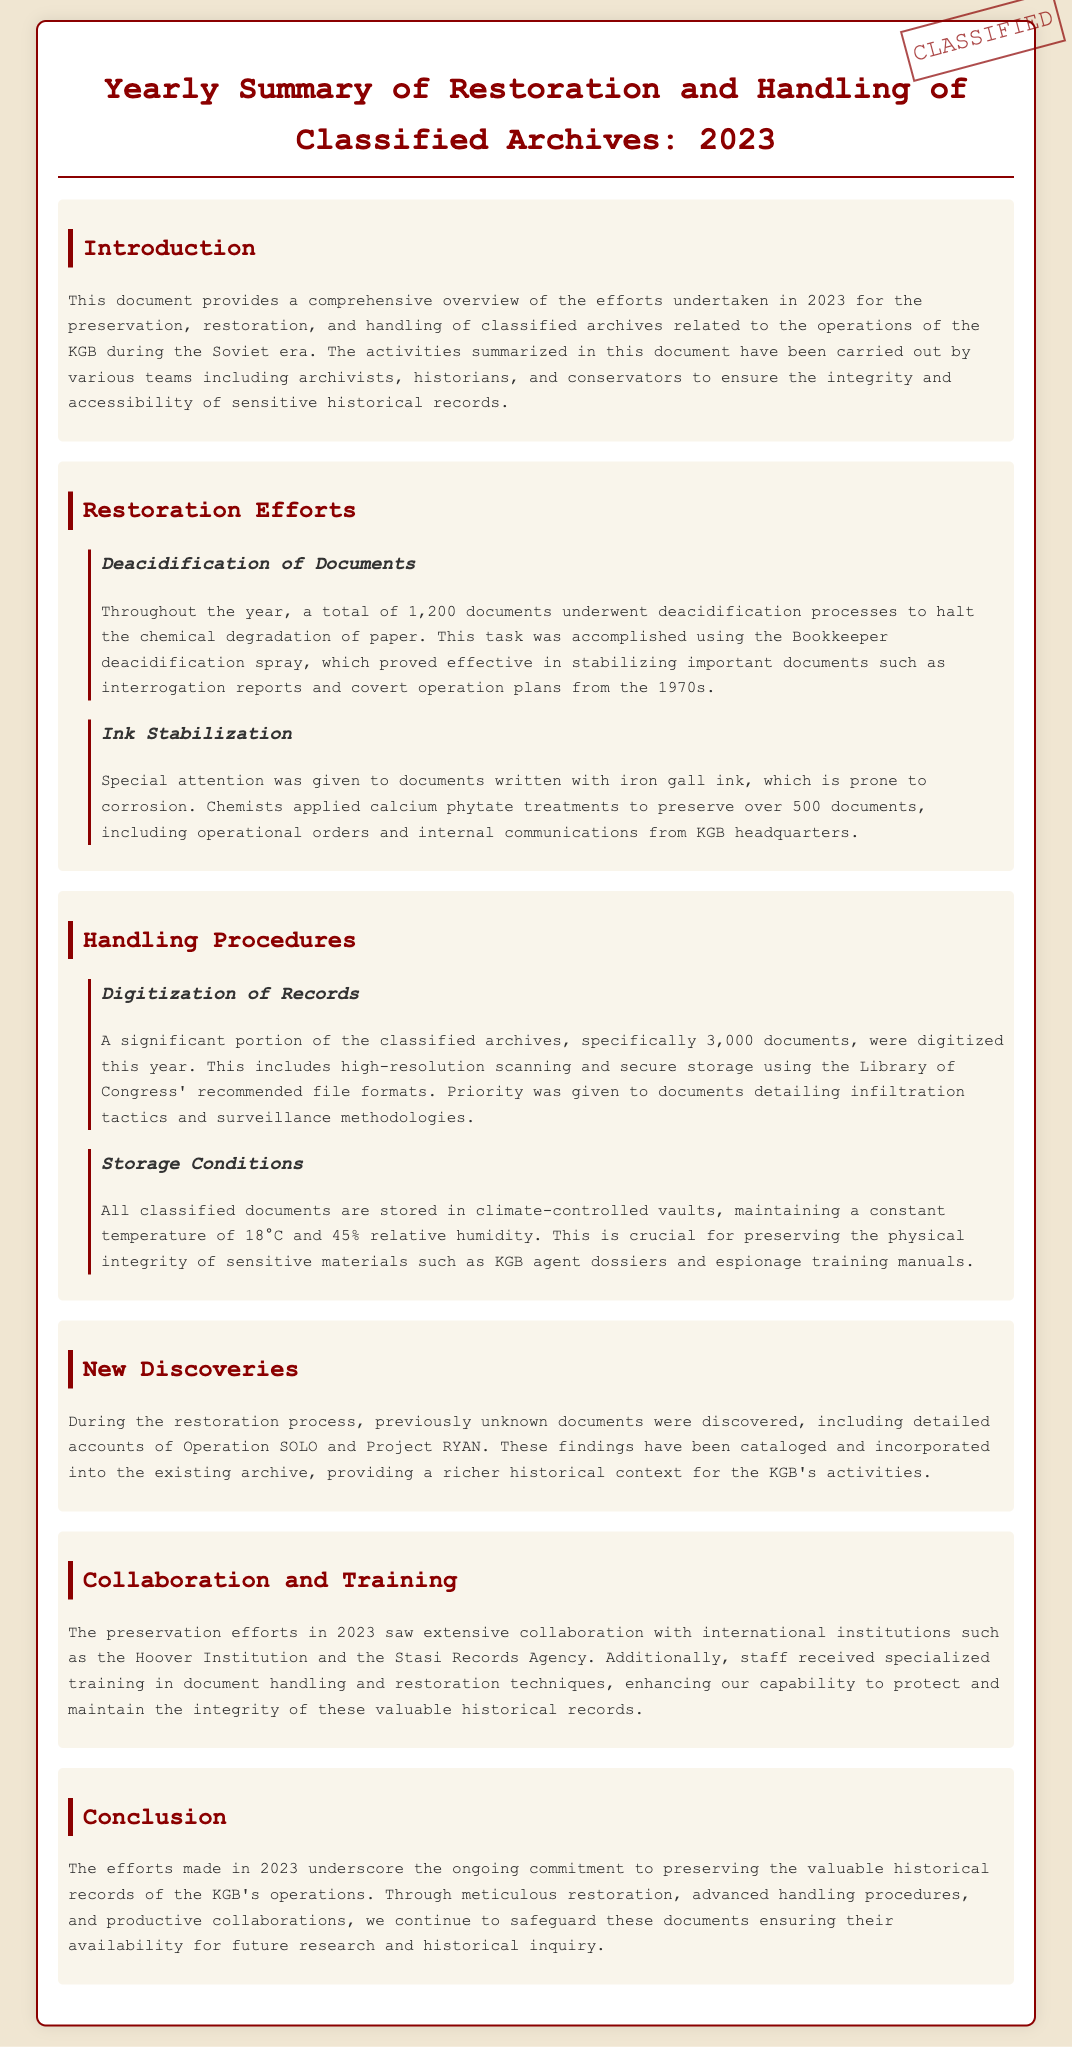what was the total number of documents that underwent deacidification in 2023? The document states that a total of 1,200 documents underwent deacidification processes to halt the chemical degradation of paper.
Answer: 1,200 how many documents were digitized during the year? According to the document, 3,000 documents were digitized this year, including high-resolution scanning and secure storage.
Answer: 3,000 which chemical treatment was applied to preserve documents written with iron gall ink? The document specifies that chemists applied calcium phytate treatments to over 500 documents that were at risk of corrosion.
Answer: calcium phytate what temperature is maintained in the climate-controlled vaults for storage? The document mentions that a constant temperature of 18°C is maintained in the climate-controlled vaults.
Answer: 18°C what significant discoveries were made during the restoration process? The document refers to the discovery of previously unknown documents, including detailed accounts of Operation SOLO and Project RYAN.
Answer: Operation SOLO and Project RYAN which institutions collaborated in the preservation efforts of 2023? The document lists extensive collaboration with international institutions such as the Hoover Institution and the Stasi Records Agency.
Answer: Hoover Institution and Stasi Records Agency how many documents required ink stabilization treatment? The document indicates that over 500 documents were treated for ink stabilization, particularly those written with iron gall ink.
Answer: 500 what type of records were prioritized during the digitization process? The document specifies that documents detailing infiltration tactics and surveillance methodologies were given priority during digitization.
Answer: infiltration tactics and surveillance methodologies 